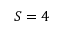<formula> <loc_0><loc_0><loc_500><loc_500>S = 4</formula> 